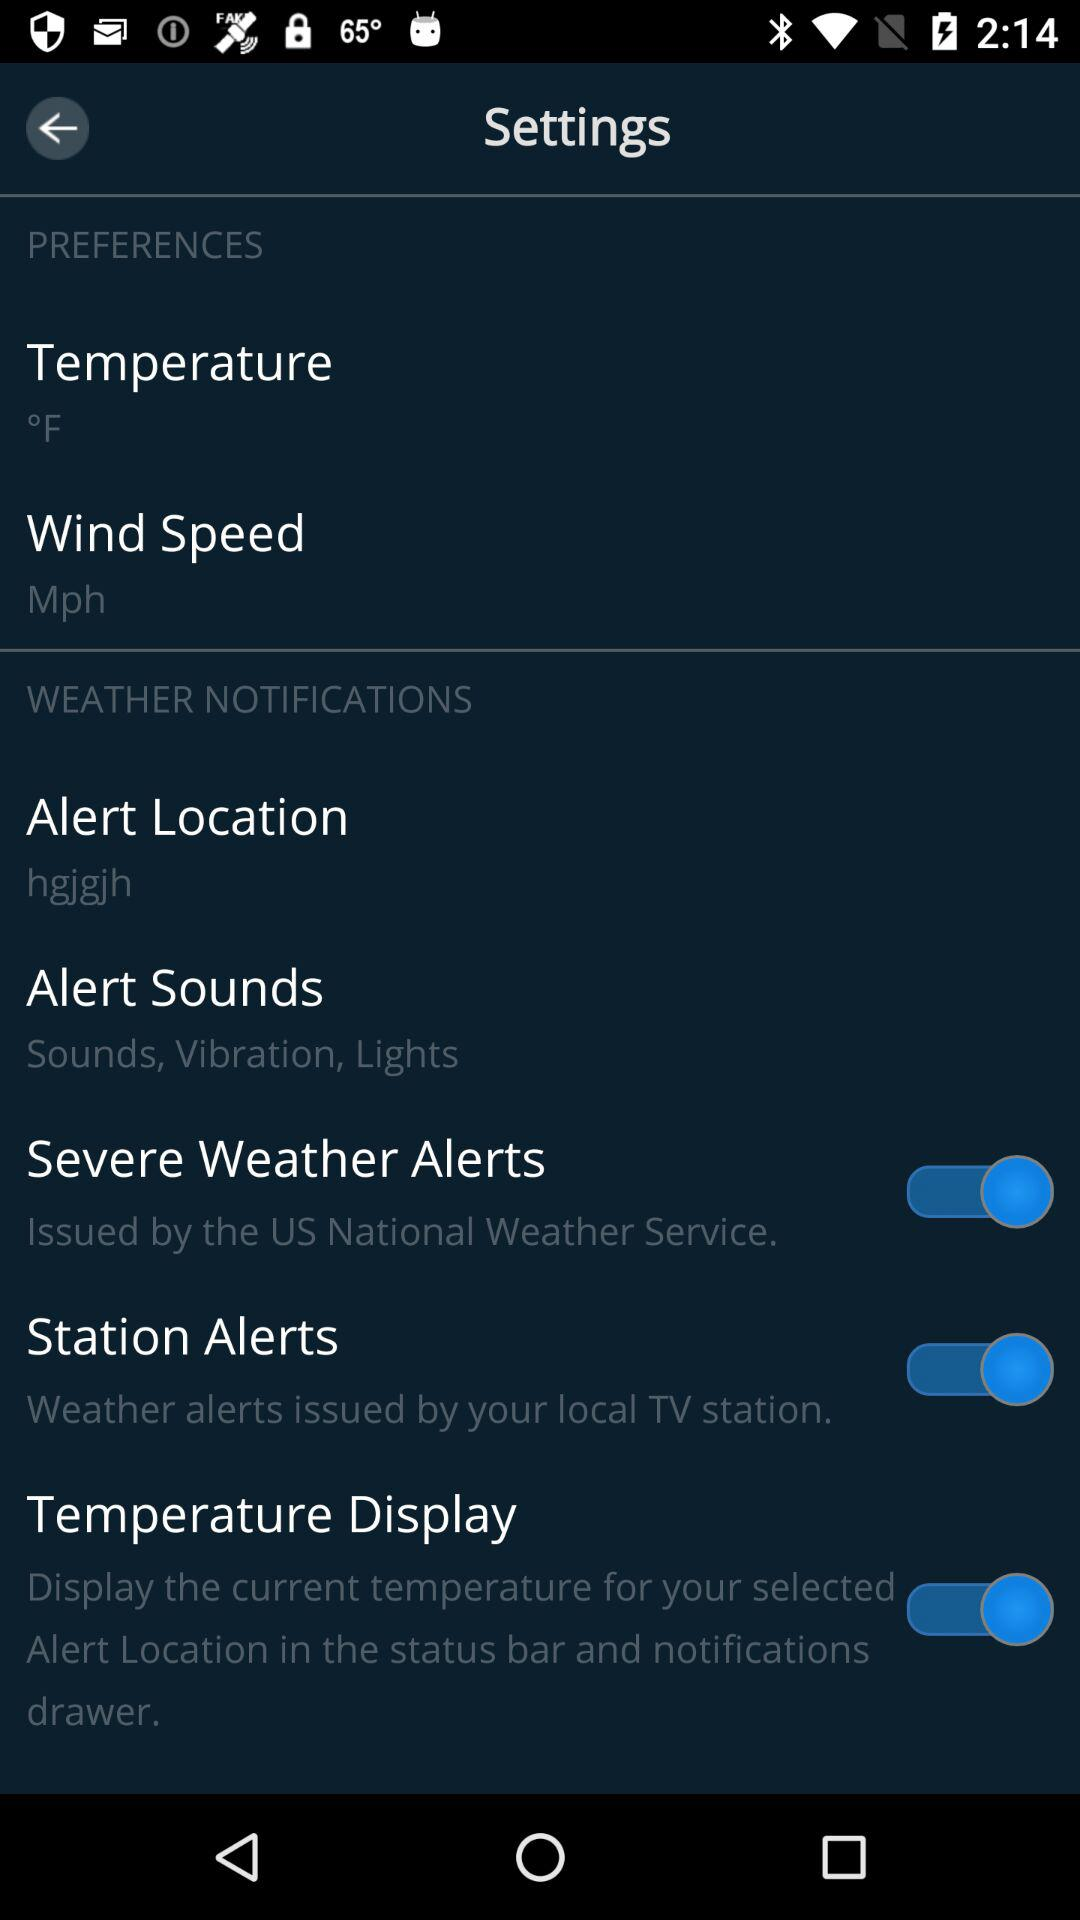What is the setting for alert location? The setting for alert location is "hgjgjh". 